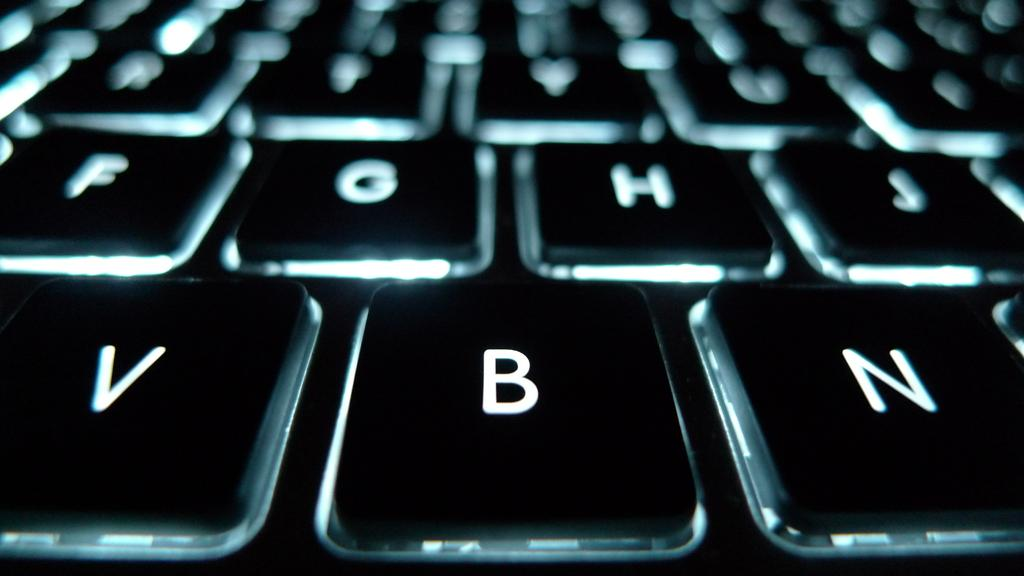<image>
Offer a succinct explanation of the picture presented. Keyboard keys that are lit up with the letter B between the V and N keys. 